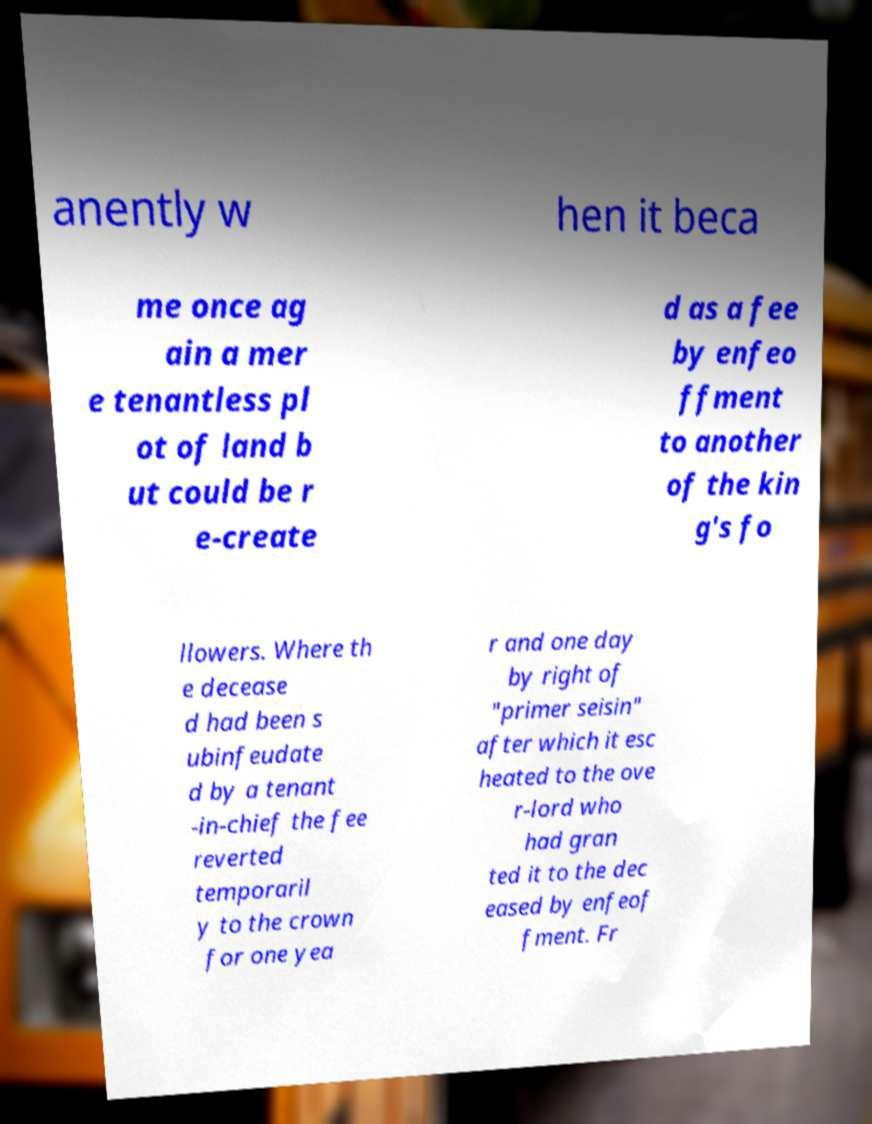Please identify and transcribe the text found in this image. anently w hen it beca me once ag ain a mer e tenantless pl ot of land b ut could be r e-create d as a fee by enfeo ffment to another of the kin g's fo llowers. Where th e decease d had been s ubinfeudate d by a tenant -in-chief the fee reverted temporaril y to the crown for one yea r and one day by right of "primer seisin" after which it esc heated to the ove r-lord who had gran ted it to the dec eased by enfeof fment. Fr 